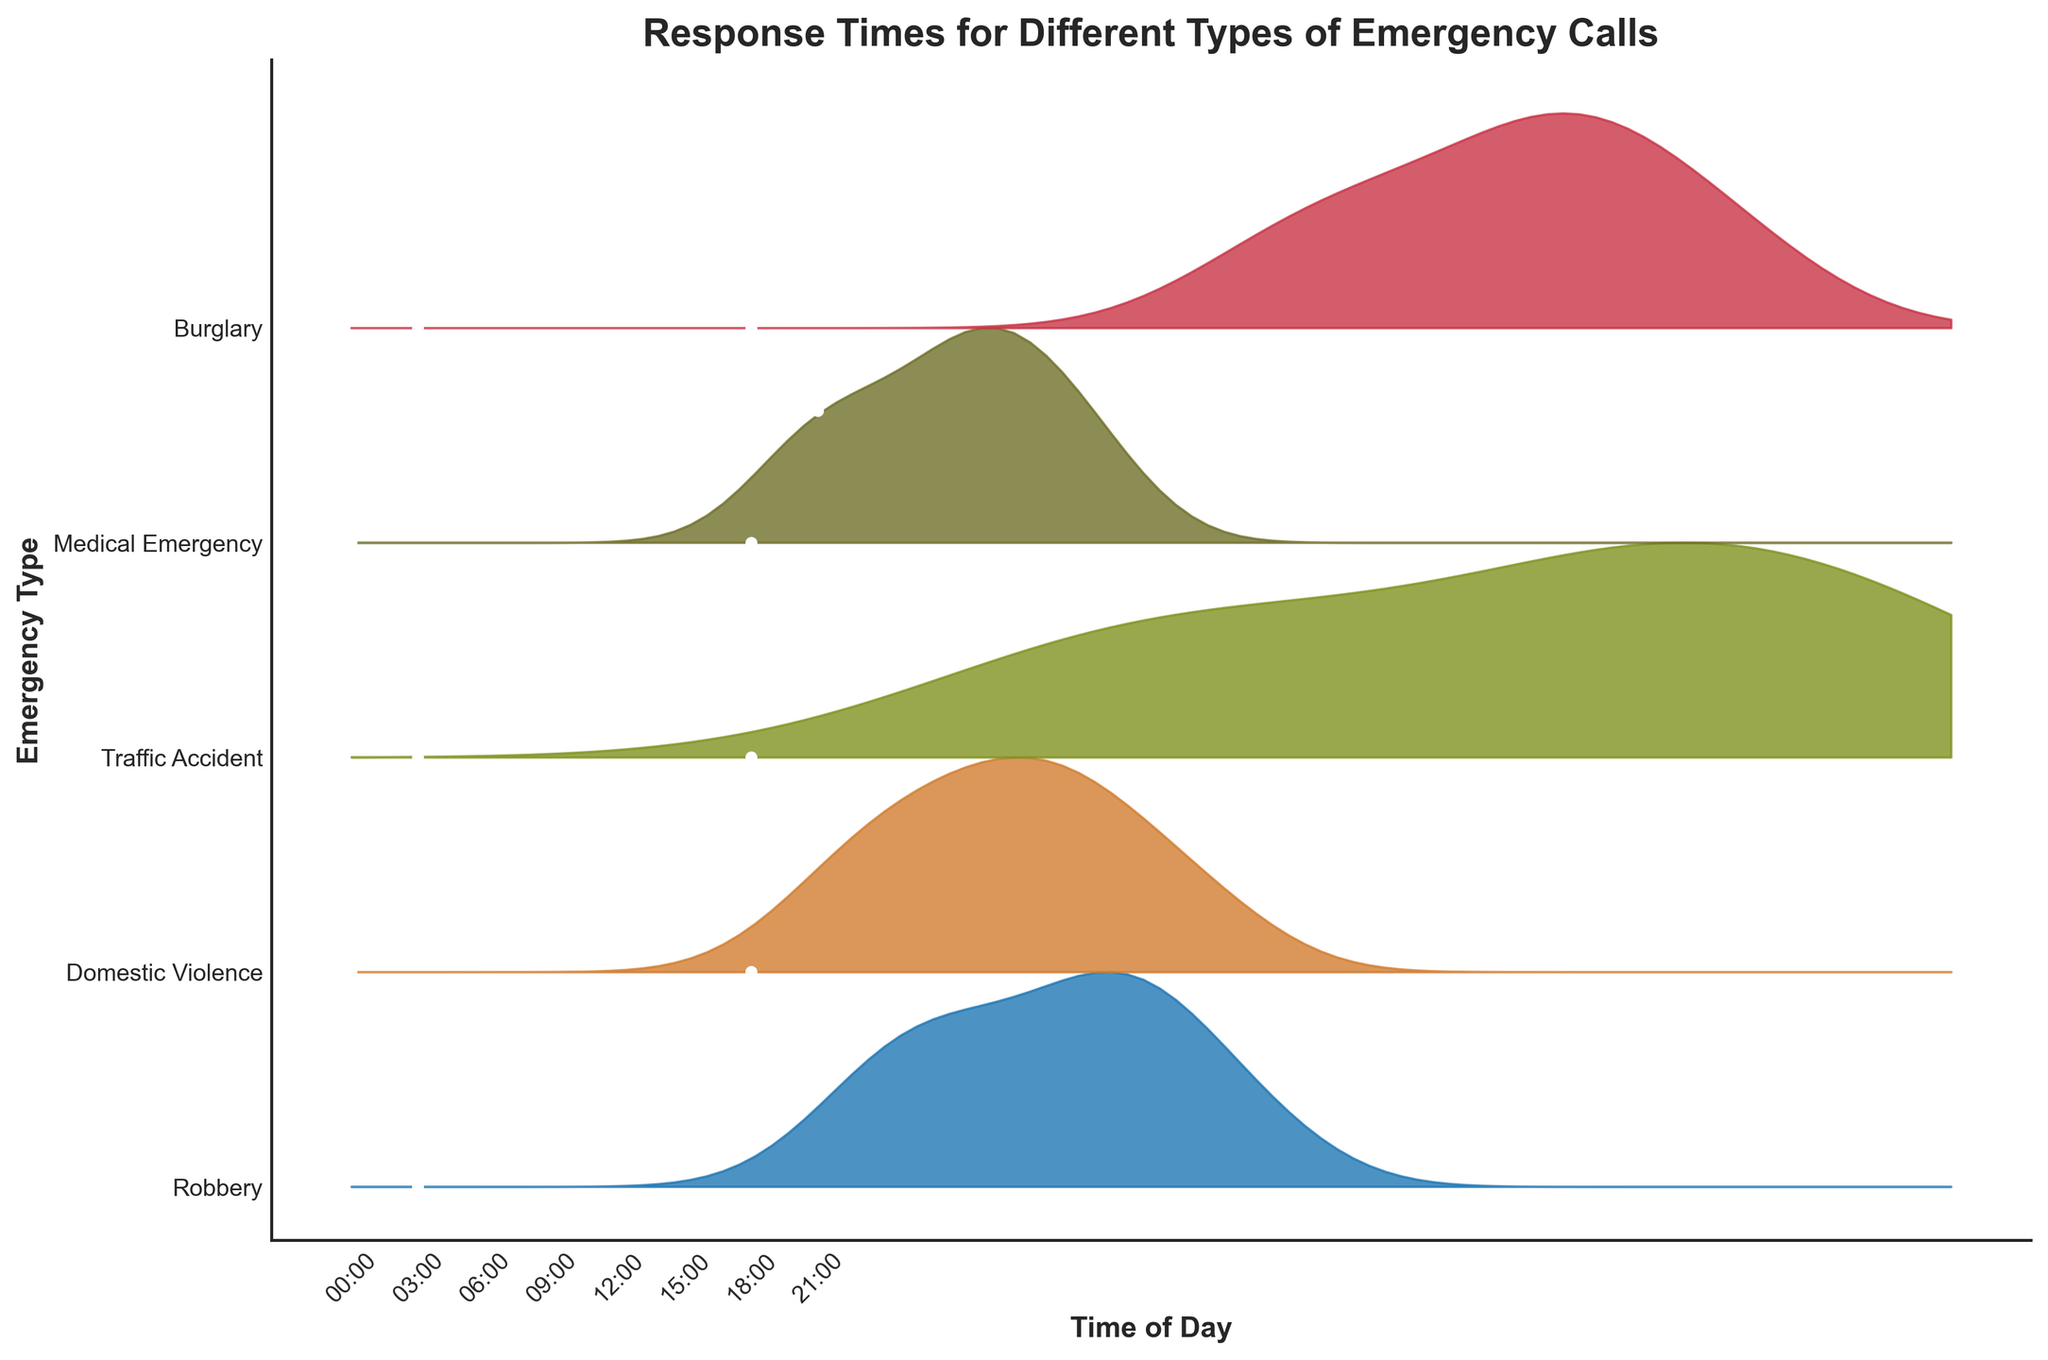What is the title of the figure? The title is typically located at the top of the plot which provides an overview of what the figure is showing. Here, "Response Times for Different Types of Emergency Calls" is visible at the top.
Answer: Response Times for Different Types of Emergency Calls What are the types of emergency calls displayed on the y-axis? The y-axis lists the various categories of emergency calls. These are usually written next to the corresponding tick marks.
Answer: Robbery, Domestic Violence, Traffic Accident, Medical Emergency, Burglary Which emergency type has the highest average response time at 15:00? To determine this, we look at the response times at the 15:00 mark and find the maximum value among the emergency types listed.
Answer: Traffic Accident How does the response time for Medical Emergency at 21:00 compare to that at 00:00? We compare the values at 21:00 and 00:00 for Medical Emergency by checking their positions on the plot.
Answer: Slightly higher at 21:00 At what time is the response time for Burglary the lowest? We identify the minimum value for Burglary and find the corresponding time on the plot.
Answer: 03:00 What is the difference in response times for Robbery between 09:00 and 18:00? We find the values for Robbery at 09:00 and 18:00 and subtract the earlier from the later to find the difference.
Answer: 2.9 Which emergency type shows the most variability in response times throughout the day? By observing the spread and peaks of the curves, we can see which one fluctuates the most. Larger spread indicates higher variability.
Answer: Traffic Accident Describe the trend in response times for Domestic Violence calls from 00:00 to 18:00. We follow the curve for Domestic Violence, noting whether the values increase, decrease, or stay constant at different times.
Answer: Generally increasing What is the range (max - min) of response times for Traffic Accident calls? For Traffic Accident, we identify the maximum and minimum response times from the plot and calculate the range by subtracting the minimum from the maximum.
Answer: 23.9 - 10.5 = 13.4 Which time of the day has the most consistent response times across all emergency types? By observing the overlapped and aligned positions of different emergency call types at each time point, we find the time with the least variability in the plot.
Answer: 03:00 